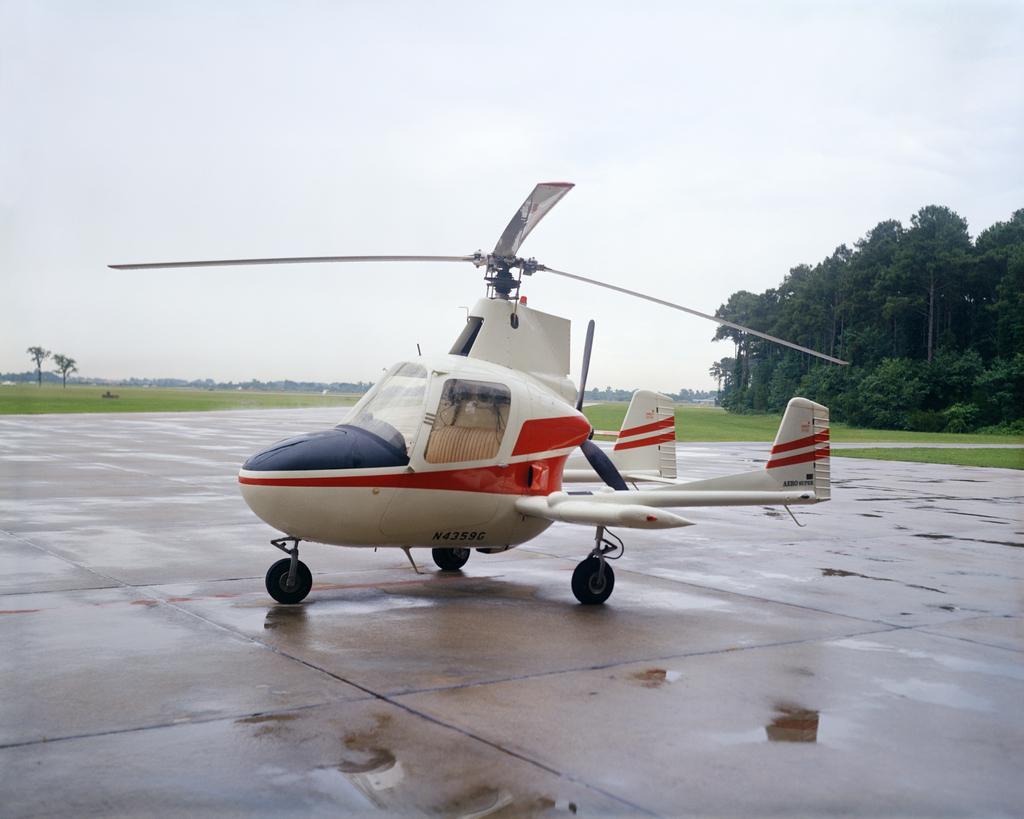In one or two sentences, can you explain what this image depicts? In this image, I can see a helicopter on the ground. On the right side of the image, there are trees. In the background, I can see the grass and the sky. 